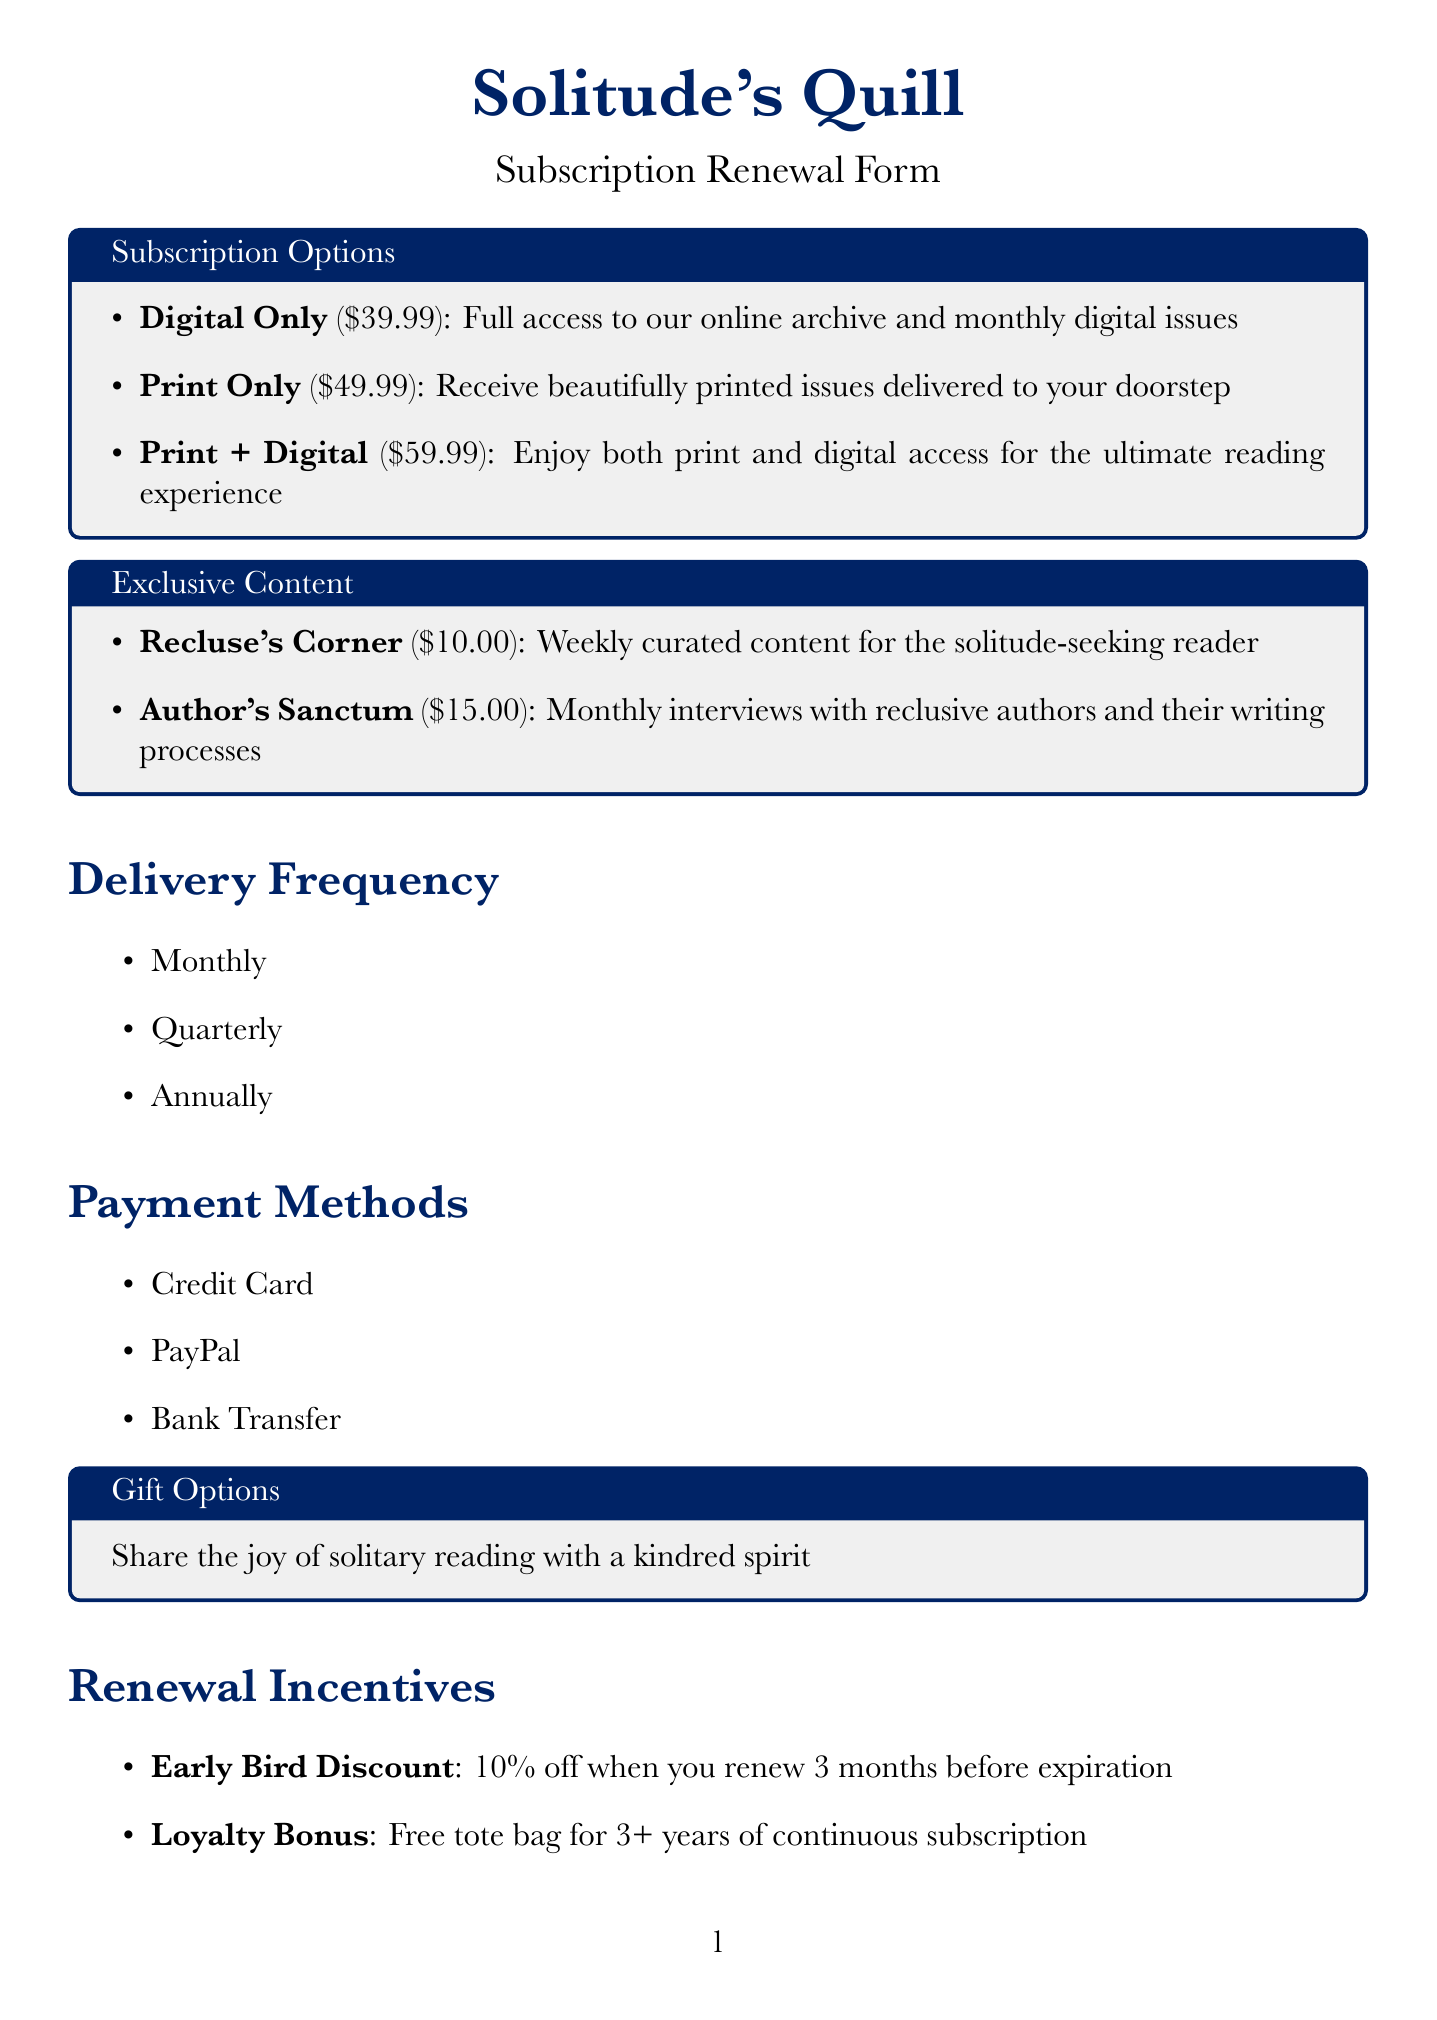What is the name of the magazine? The name of the magazine is mentioned at the beginning of the document.
Answer: Solitude's Quill What is the price of the Print + Digital option? The price for Print + Digital is listed under Subscription Options.
Answer: $59.99 How often can subscriptions be delivered? The delivery frequency options are mentioned in a specific section.
Answer: Monthly, Quarterly, Annually What is the title of the exclusive content called "Author's Sanctum"? The description for "Author's Sanctum" is given in the Exclusive Content section.
Answer: Monthly interviews with reclusive authors and their writing processes What discount is offered for renewing early? The early bird discount is explicitly stated in the Renewal Incentives section.
Answer: 10% off What genres are recommended for personalized reading? The genres for personalized recommendations are listed in the document.
Answer: Gothic Literature, Existential Fiction, Psychological Thrillers, Poetry Collections Is there an option to gift a subscription? The document contains a specific section about gift options.
Answer: Yes What type of headphones do subscribers get discounts on? The subscriber benefits section mentions specific discounts.
Answer: Noise-cancelling headphones 